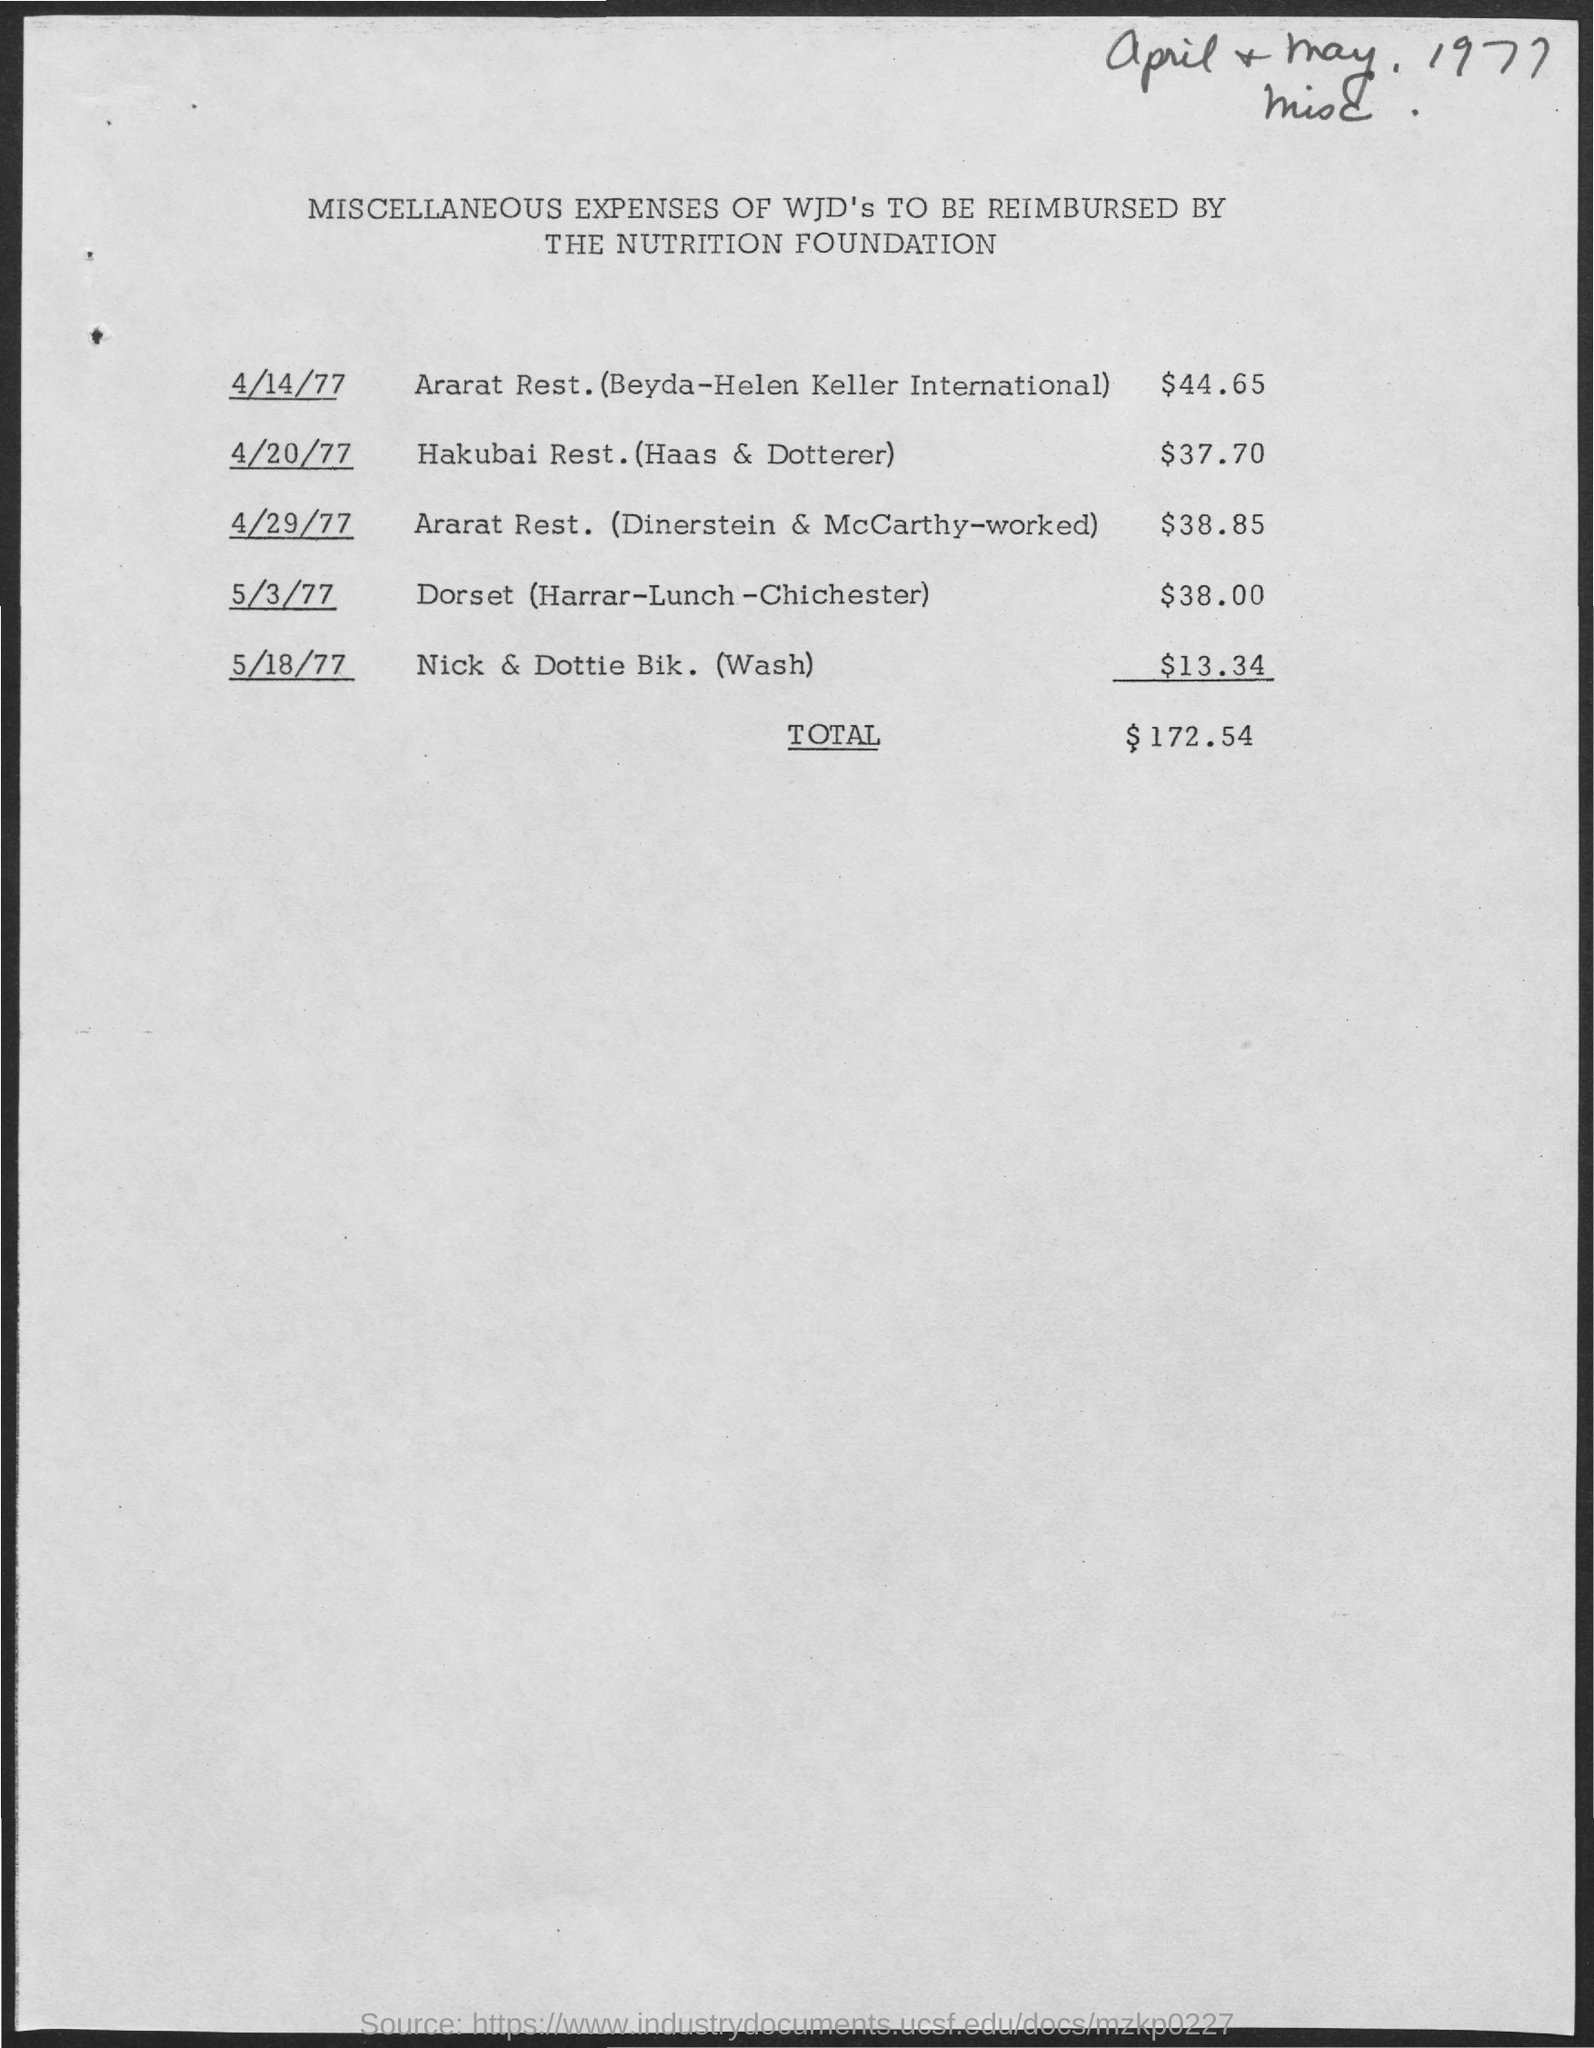Outline some significant characteristics in this image. The total expenses of Hakubai Rest (Haas & Dotterer) were $37.70. The document is titled 'Miscellaneous Expenses of WJD's to be Reimbursed by The Nutrition Foundation.' The total expenses to be reimbursed is $172.54. 